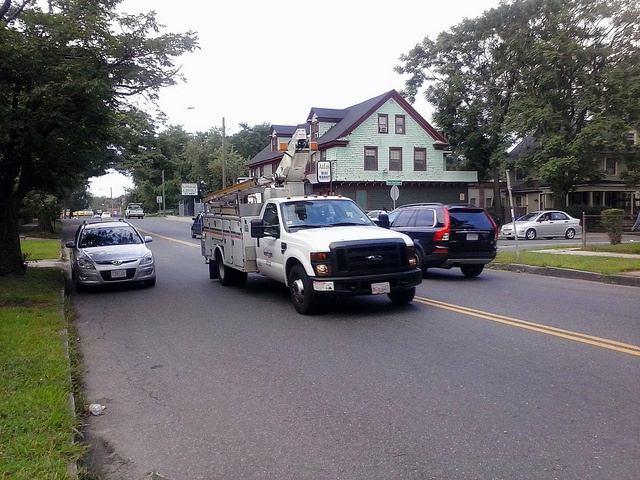Describe the objects in this image and their specific colors. I can see truck in white, black, gray, and darkgray tones, car in white, black, darkgray, and gray tones, car in white, black, lavender, gray, and darkgray tones, car in white, darkgray, lightgray, gray, and black tones, and car in white, gray, darkgray, black, and lightgray tones in this image. 